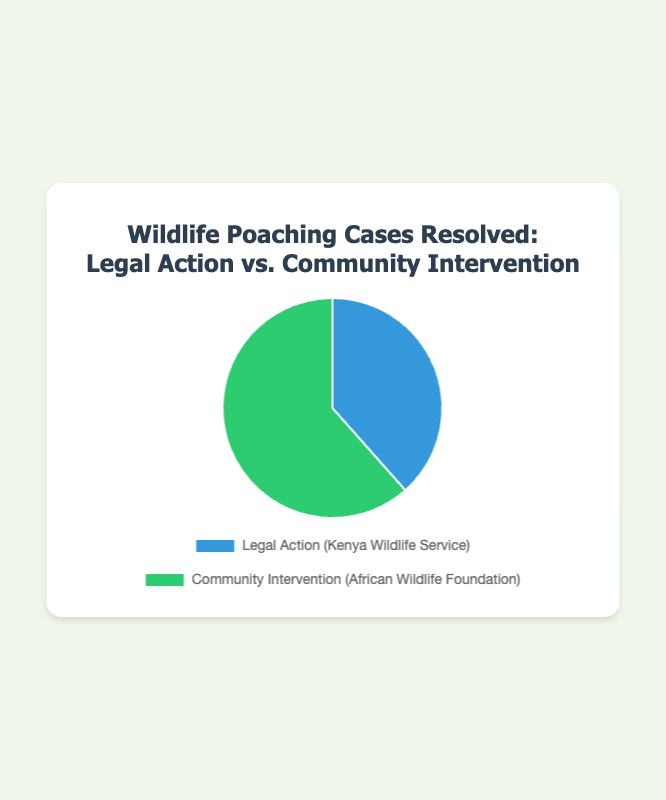Which method resolved the most wildlife poaching cases? The pie chart shows two methods: Legal Action with 150 cases and Community Intervention with 240 cases. By comparing these values, we see that Community Intervention resolved more cases.
Answer: Community Intervention What's the total number of poaching cases resolved by both methods together? By summing the cases resolved by Legal Action (150 cases) and Community Intervention (240 cases), we get a total of 150 + 240 = 390 cases.
Answer: 390 By what percentage is Community Intervention more effective than Legal Action in resolving cases? First, find the difference in cases resolved (240 - 150 = 90). Then, calculate the percentage increase: (90 / 150) * 100% ≈ 60%.
Answer: 60% What's the share of Legal Action in the resolved cases as a percentage? There are 150 cases resolved by Legal Action out of a total of 390 cases. To find the percentage: (150 / 390) * 100% ≈ 38.5%.
Answer: 38.5% What color represents Community Intervention in the pie chart? The pie chart uses green to represent Community Intervention. This information is visually identifiable through the color legend.
Answer: Green What method is represented by the blue color? The pie chart uses blue to represent Legal Action. This information is visually identifiable through the color legend.
Answer: Legal Action What's the difference in the number of cases resolved by Community Intervention compared to Legal Action? The number of cases resolved by Community Intervention is 240, and by Legal Action is 150. The difference is 240 - 150 = 90 cases.
Answer: 90 If 30 cases were added to those resolved by Legal Action, would it surpass Community Intervention? Adding 30 cases to Legal Action results in 150 + 30 = 180 cases, which is still less than the 240 cases resolved by Community Intervention.
Answer: No How much more effective is Community Intervention compared to Legal Action in terms of absolute cases resolved? Community Intervention resolved 240 cases, while Legal Action resolved 150 cases. The effectiveness difference is 240 - 150 = 90 cases.
Answer: 90 If the total number of resolved cases increased by 100, maintaining the same ratio, how many cases should be resolved by Legal Action? The current ratio of Legal Action cases to the total is 150/390. If the total increases by 100 to 490, the cases resolved by Legal Action are (150/390)*490 ≈ 188.
Answer: 188 